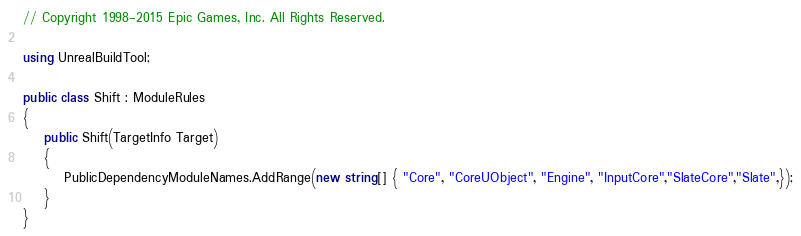Convert code to text. <code><loc_0><loc_0><loc_500><loc_500><_C#_>// Copyright 1998-2015 Epic Games, Inc. All Rights Reserved.

using UnrealBuildTool;

public class Shift : ModuleRules
{
	public Shift(TargetInfo Target)
	{
		PublicDependencyModuleNames.AddRange(new string[] { "Core", "CoreUObject", "Engine", "InputCore","SlateCore","Slate",});
	}
}
</code> 